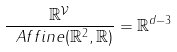Convert formula to latex. <formula><loc_0><loc_0><loc_500><loc_500>\frac { \mathbb { R } ^ { \mathcal { V } } } { \ A f f i n e ( \mathbb { R } ^ { 2 } , \mathbb { R } ) } = \mathbb { R } ^ { d - 3 }</formula> 